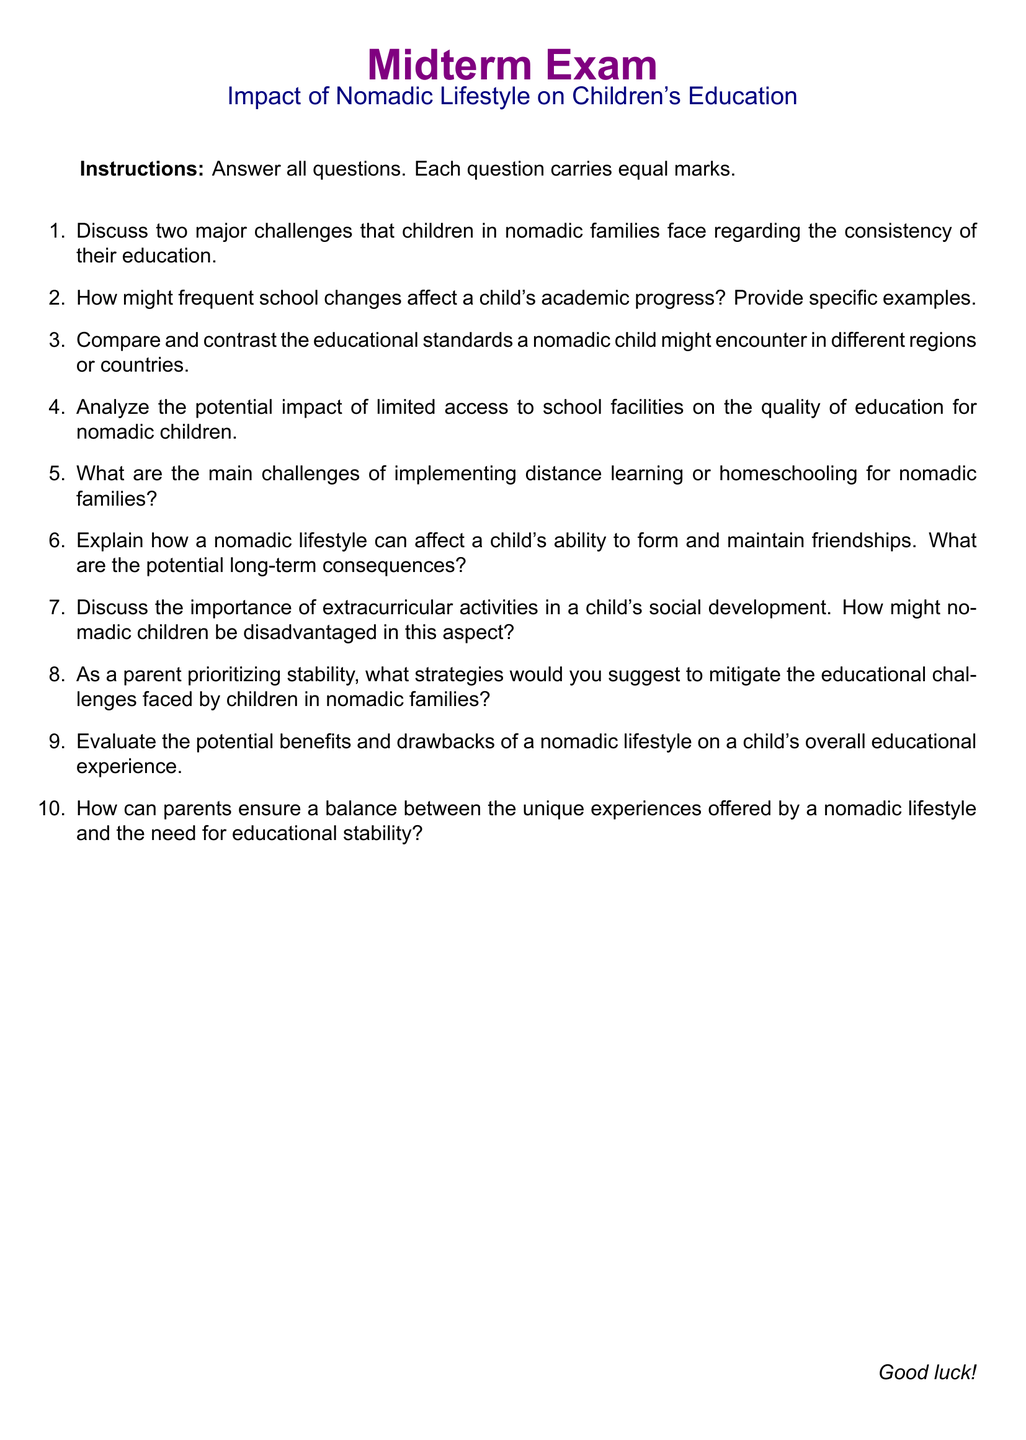What is the document title? The title of the document is given at the beginning, highlighting the focus of the exam.
Answer: Midterm Exam What is the subtitle of the document? The subtitle provides specific information about the topic being examined in the document.
Answer: Impact of Nomadic Lifestyle on Children's Education How many questions are there in the exam? The total number of questions is indicated in the enumeration format used in the document.
Answer: Ten What color is used for section titles? The specific color used for distinguishing section titles is stated in the document.
Answer: Purple What is the format of the questions in this midterm exam? The format used for the exam questions is specified, indicating how they should be answered.
Answer: Short-answer questions Which aspect of children's development is mentioned as being potentially disadvantaged for nomadic children? The document addresses a specific element of children's development regarding their social connections.
Answer: Extracurricular activities What instructional note is included for the exam? An instruction is provided at the beginning regarding how students should approach the exam.
Answer: Answer all questions How might a nomadic lifestyle influence a child's friendships? This question involves the context of social relationships in the lives of nomadic children.
Answer: Maintaining friendships What does the instruction mention about the marks assigned to the questions? The instruction clarifies the evaluation criteria for the midterm exam questions.
Answer: Equal marks What is the concluding phrase in the document? The conclusion typically offers encouragement or well wishes to the examinees.
Answer: Good luck! 